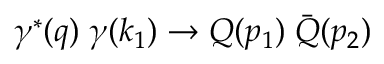<formula> <loc_0><loc_0><loc_500><loc_500>\gamma ^ { \ast } ( q ) \, \gamma ( k _ { 1 } ) \rightarrow Q ( p _ { 1 } ) \, \bar { Q } ( p _ { 2 } )</formula> 